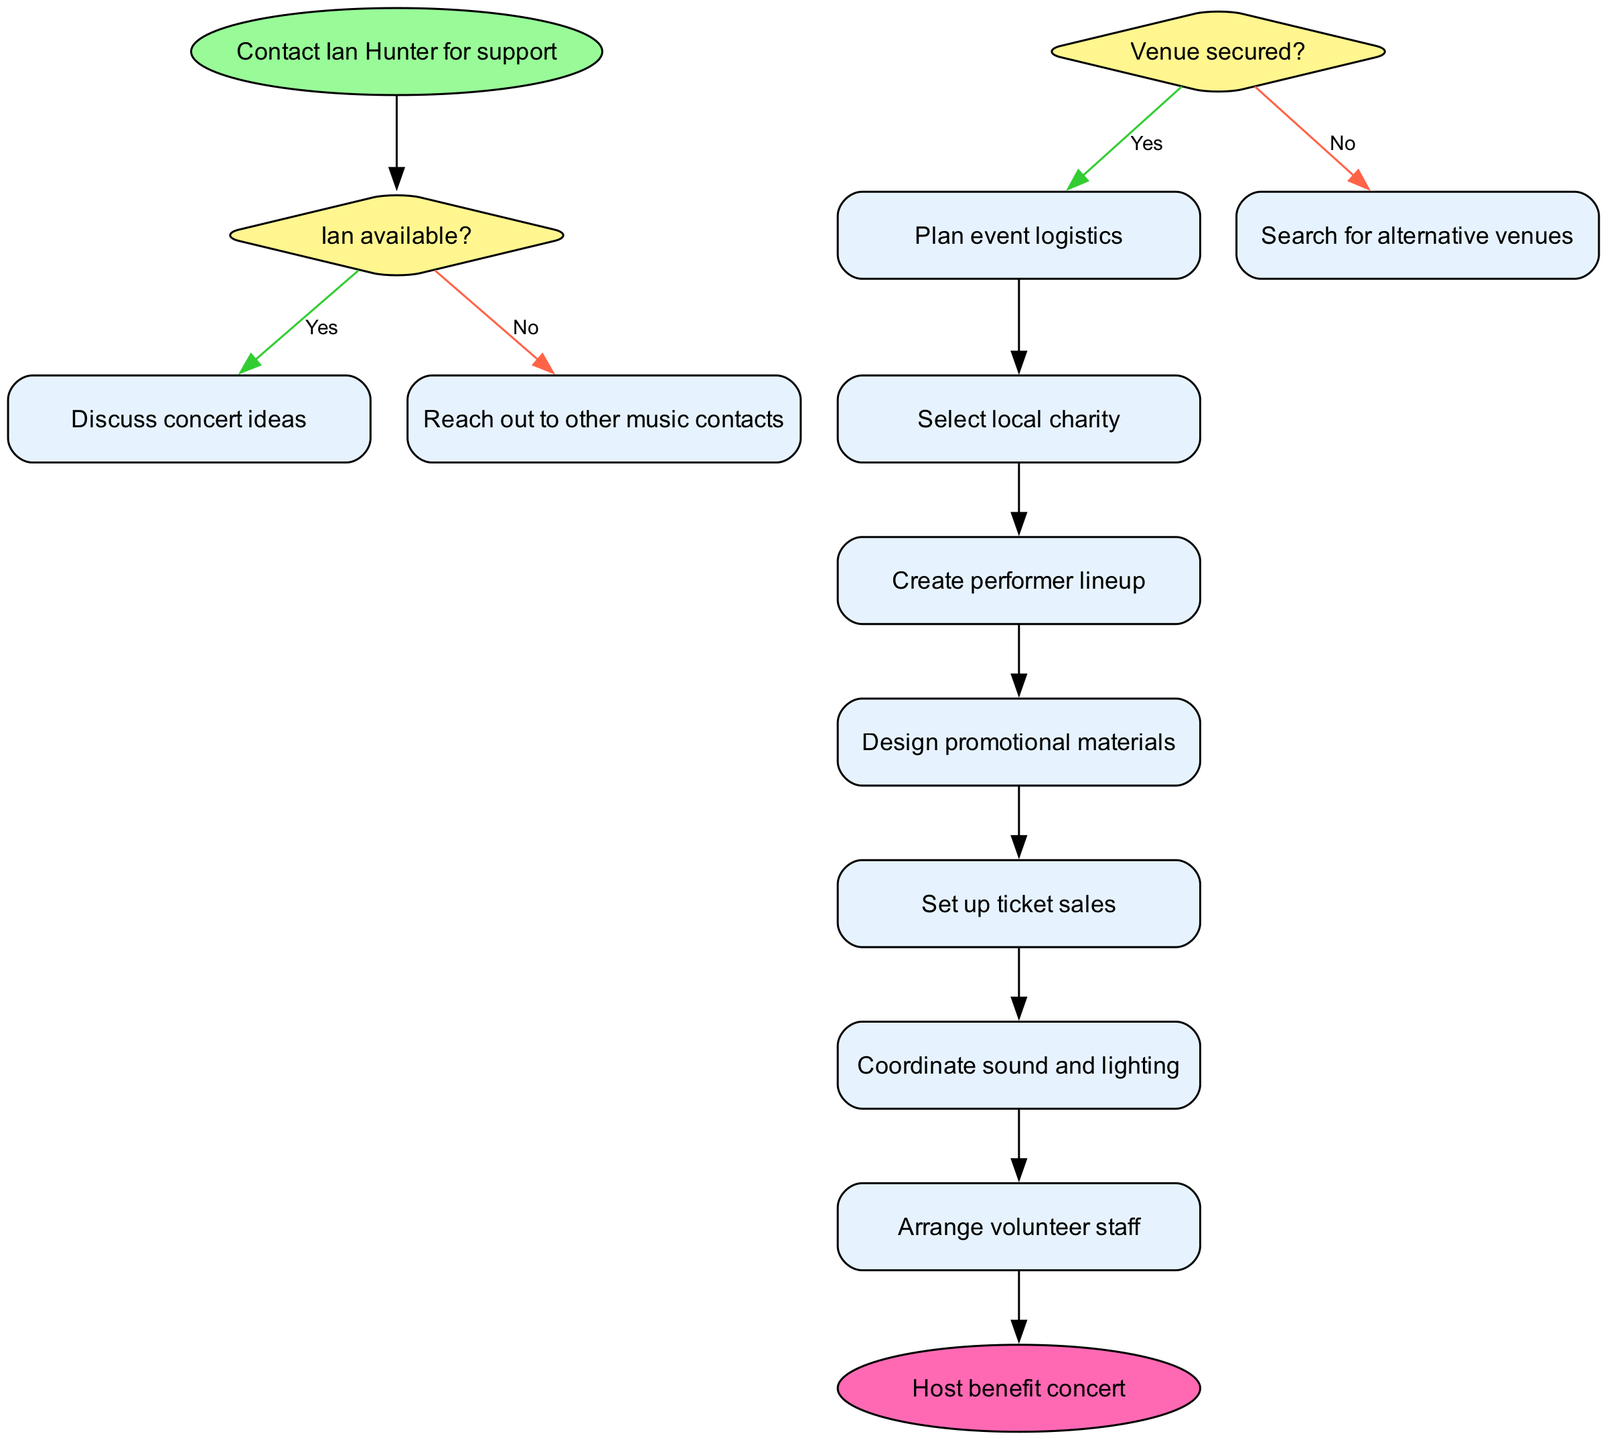What is the first action after discussing concert ideas? After the decision about the availability of Ian, if he is available, the next step is to discuss concert ideas. Following that, the first action listed is to select a local charity.
Answer: Select local charity How many actions are listed in the diagram? The diagram outlines a total of six actions that need to be carried out after the decisions about venue and concert ideas.
Answer: 6 What happens if the venue is not secured? If the venue is not secured, the flow indicates to search for alternative venues as the next step. This decision comes after the node asking about the venue.
Answer: Search for alternative venues What is the end node of the flow chart? The end node, based on the diagram, is clearly marked as the final outcome of the actions, which states to host the benefit concert.
Answer: Host benefit concert What is the second decision in the flow chart? The second decision in the diagram addresses whether the venue has been secured or not. This follows the initial check on Ian's availability.
Answer: Venue secured? What connects the decision about Ian’s availability to the action nodes? The nodes are connected by the "yes" edge from the decision about Ian's availability leading directly to discussing concert ideas, thus forming the path to the action nodes starting from there.
Answer: Discuss concert ideas Which action is directly linked to the decision "Venue secured?" if the answer is yes? If the venue is secured, the next action in the flow chart is to plan event logistics, thus directly stemming from that decision.
Answer: Plan event logistics What action must be completed immediately after selecting a local charity? Following the selection of the local charity, the next action identified in the flow chart is to create a performer lineup, indicating a sequential approach to organizing the concert.
Answer: Create performer lineup 